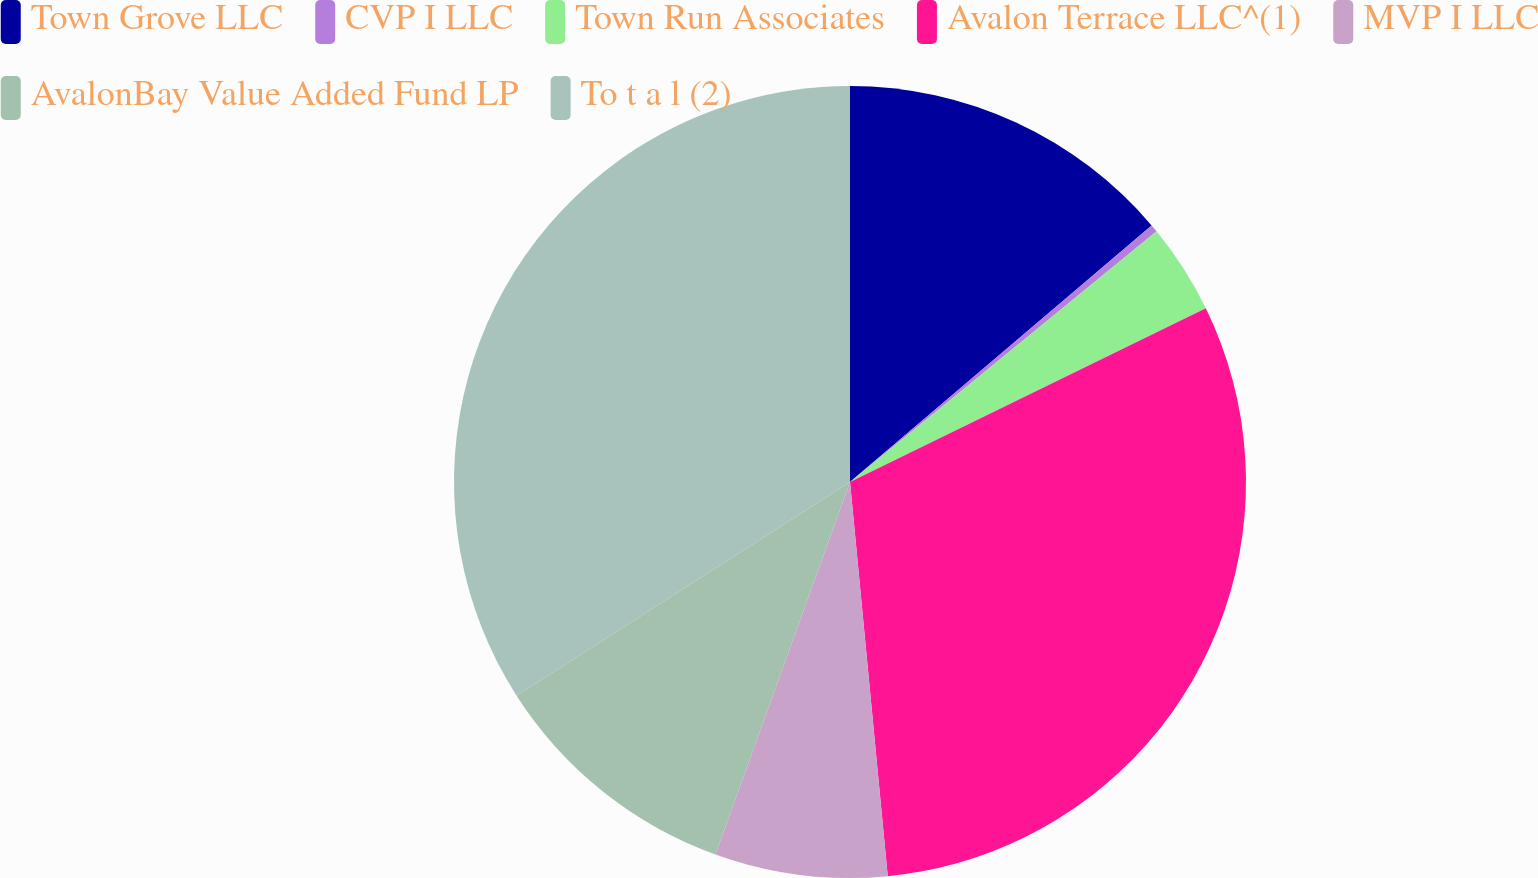Convert chart to OTSL. <chart><loc_0><loc_0><loc_500><loc_500><pie_chart><fcel>Town Grove LLC<fcel>CVP I LLC<fcel>Town Run Associates<fcel>Avalon Terrace LLC^(1)<fcel>MVP I LLC<fcel>AvalonBay Value Added Fund LP<fcel>To t a l (2)<nl><fcel>13.78%<fcel>0.31%<fcel>3.68%<fcel>30.71%<fcel>7.04%<fcel>10.41%<fcel>34.07%<nl></chart> 